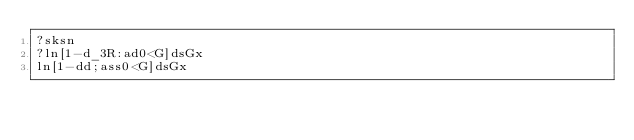<code> <loc_0><loc_0><loc_500><loc_500><_dc_>?sksn
?ln[1-d_3R:ad0<G]dsGx
ln[1-dd;ass0<G]dsGx</code> 